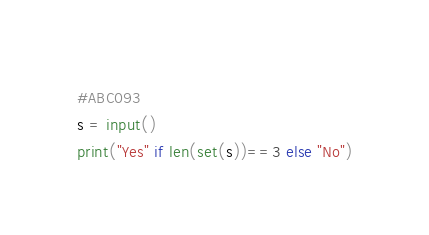<code> <loc_0><loc_0><loc_500><loc_500><_Python_>#ABC093
s = input()
print("Yes" if len(set(s))==3 else "No")</code> 